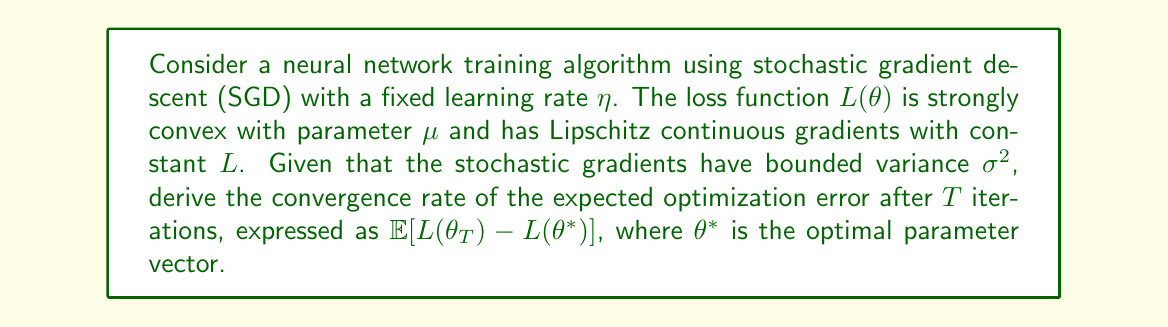Can you answer this question? To analyze the convergence rate of this neural network training algorithm, we'll follow these steps:

1) For strongly convex functions with Lipschitz continuous gradients, the SGD update rule is:

   $$\theta_{t+1} = \theta_t - \eta \nabla L_t(\theta_t)$$

   where $\nabla L_t(\theta_t)$ is the stochastic gradient at iteration $t$.

2) The convergence analysis relies on the following properties:
   - Strong convexity: $L(\theta) - L(\theta^*) \geq \frac{\mu}{2}\|\theta - \theta^*\|^2$
   - Lipschitz continuity of gradients: $\|\nabla L(\theta) - \nabla L(\theta')\| \leq L\|\theta - \theta'\|$
   - Bounded variance of stochastic gradients: $\mathbb{E}[\|\nabla L_t(\theta) - \nabla L(\theta)\|^2] \leq \sigma^2$

3) Using these properties, we can derive the following inequality for the expected decrease in distance to the optimum:

   $$\mathbb{E}[\|\theta_{t+1} - \theta^*\|^2] \leq (1-\eta\mu)\|\theta_t - \theta^*\|^2 + \eta^2\sigma^2$$

4) Recursively applying this inequality over $T$ iterations yields:

   $$\mathbb{E}[\|\theta_T - \theta^*\|^2] \leq (1-\eta\mu)^T\|\theta_0 - \theta^*\|^2 + \frac{\eta\sigma^2}{\mu}$$

5) Using the strong convexity property, we can relate this to the optimization error:

   $$\mathbb{E}[L(\theta_T) - L(\theta^*)] \leq \frac{L}{2}\mathbb{E}[\|\theta_T - \theta^*\|^2]$$

6) Substituting the result from step 4 into this inequality:

   $$\mathbb{E}[L(\theta_T) - L(\theta^*)] \leq \frac{L}{2}(1-\eta\mu)^T\|\theta_0 - \theta^*\|^2 + \frac{L\eta\sigma^2}{2\mu}$$

7) The optimal fixed learning rate that minimizes this bound is $\eta = \frac{1}{L}$. Substituting this:

   $$\mathbb{E}[L(\theta_T) - L(\theta^*)] \leq \frac{L}{2}(1-\frac{\mu}{L})^T\|\theta_0 - \theta^*\|^2 + \frac{\sigma^2}{2\mu L}$$

This expression gives us the convergence rate of the expected optimization error after $T$ iterations.
Answer: The convergence rate of the expected optimization error after $T$ iterations is:

$$\mathbb{E}[L(\theta_T) - L(\theta^*)] \leq \frac{L}{2}(1-\frac{\mu}{L})^T\|\theta_0 - \theta^*\|^2 + \frac{\sigma^2}{2\mu L}$$

This shows a linear convergence rate of $(1-\frac{\mu}{L})^T$ to a neighborhood of the optimum, with the size of the neighborhood determined by the variance of the stochastic gradients. 